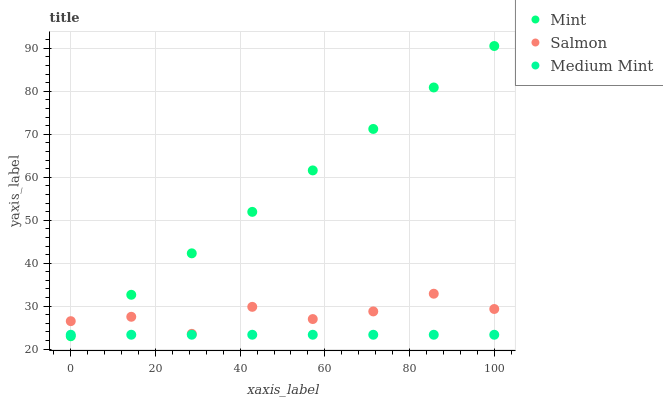Does Medium Mint have the minimum area under the curve?
Answer yes or no. Yes. Does Mint have the maximum area under the curve?
Answer yes or no. Yes. Does Salmon have the minimum area under the curve?
Answer yes or no. No. Does Salmon have the maximum area under the curve?
Answer yes or no. No. Is Mint the smoothest?
Answer yes or no. Yes. Is Salmon the roughest?
Answer yes or no. Yes. Is Salmon the smoothest?
Answer yes or no. No. Is Mint the roughest?
Answer yes or no. No. Does Mint have the lowest value?
Answer yes or no. Yes. Does Salmon have the lowest value?
Answer yes or no. No. Does Mint have the highest value?
Answer yes or no. Yes. Does Salmon have the highest value?
Answer yes or no. No. Is Medium Mint less than Salmon?
Answer yes or no. Yes. Is Salmon greater than Medium Mint?
Answer yes or no. Yes. Does Mint intersect Salmon?
Answer yes or no. Yes. Is Mint less than Salmon?
Answer yes or no. No. Is Mint greater than Salmon?
Answer yes or no. No. Does Medium Mint intersect Salmon?
Answer yes or no. No. 